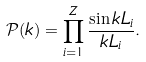<formula> <loc_0><loc_0><loc_500><loc_500>\mathcal { P } ( k ) = \prod _ { i = 1 } ^ { Z } \frac { \sin k L _ { i } } { k L _ { i } } .</formula> 